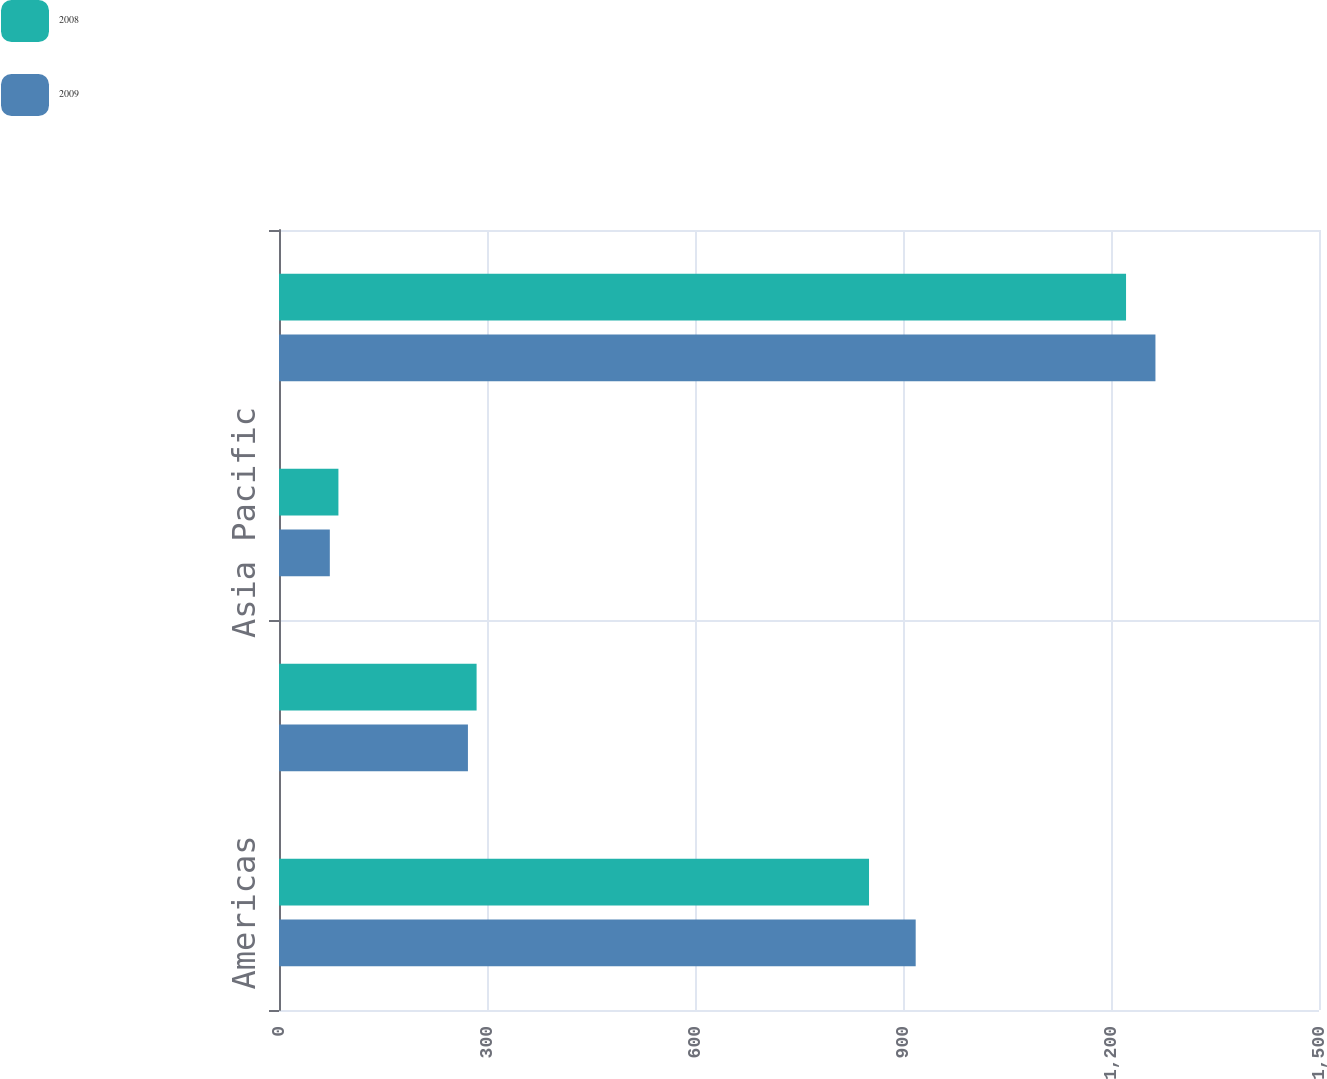<chart> <loc_0><loc_0><loc_500><loc_500><stacked_bar_chart><ecel><fcel>Americas<fcel>Europe<fcel>Asia Pacific<fcel>Total<nl><fcel>2008<fcel>851<fcel>285<fcel>85.7<fcel>1221.7<nl><fcel>2009<fcel>918.3<fcel>272.5<fcel>73.3<fcel>1264.1<nl></chart> 